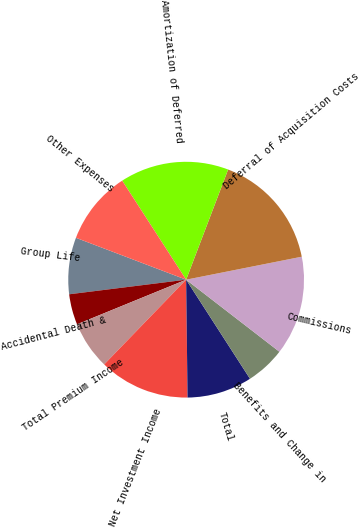Convert chart. <chart><loc_0><loc_0><loc_500><loc_500><pie_chart><fcel>Group Life<fcel>Accidental Death &<fcel>Total Premium Income<fcel>Net Investment Income<fcel>Total<fcel>Benefits and Change in<fcel>Commissions<fcel>Deferral of Acquisition Costs<fcel>Amortization of Deferred<fcel>Other Expenses<nl><fcel>7.76%<fcel>4.2%<fcel>6.59%<fcel>12.42%<fcel>8.92%<fcel>5.42%<fcel>13.59%<fcel>16.08%<fcel>14.92%<fcel>10.09%<nl></chart> 